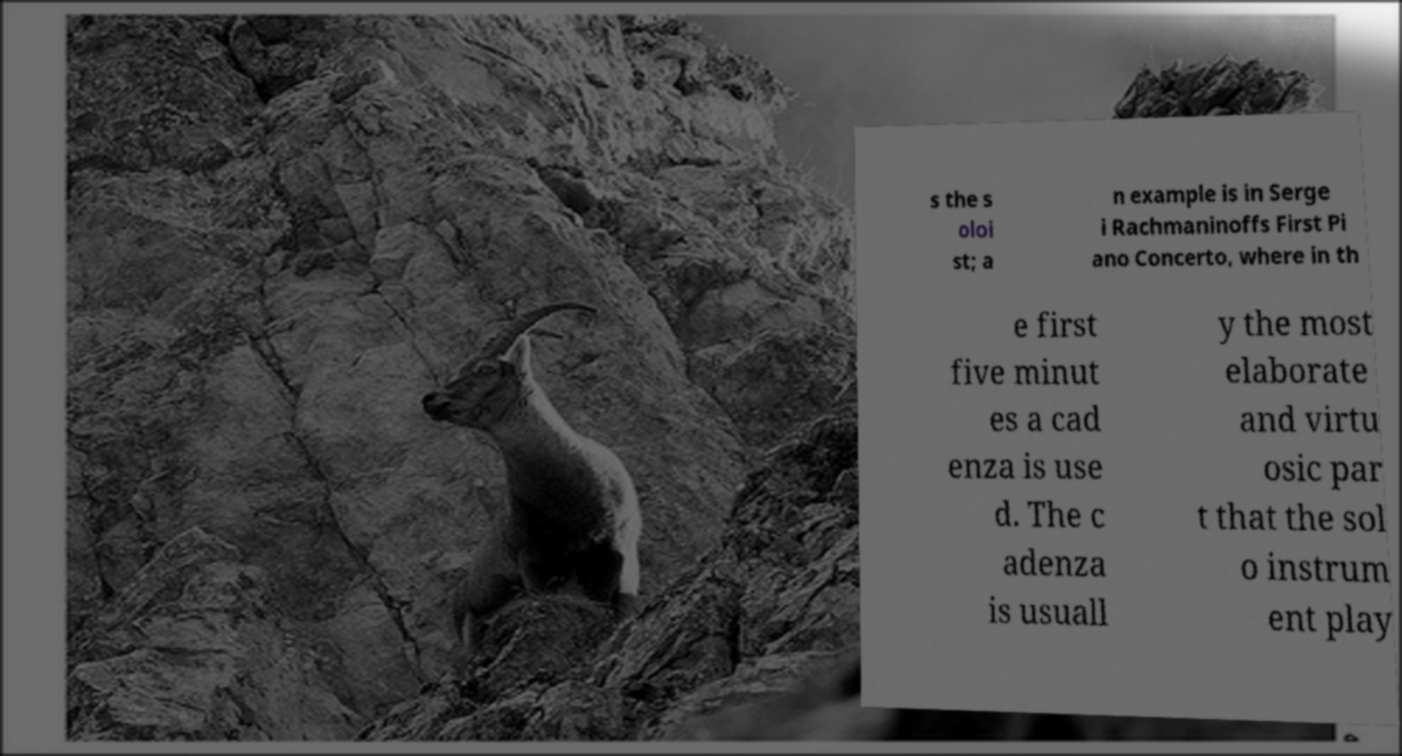Please read and relay the text visible in this image. What does it say? s the s oloi st; a n example is in Serge i Rachmaninoffs First Pi ano Concerto, where in th e first five minut es a cad enza is use d. The c adenza is usuall y the most elaborate and virtu osic par t that the sol o instrum ent play 